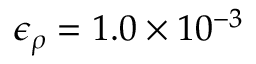Convert formula to latex. <formula><loc_0><loc_0><loc_500><loc_500>\epsilon _ { \rho } = 1 . 0 \times 1 0 ^ { - 3 }</formula> 